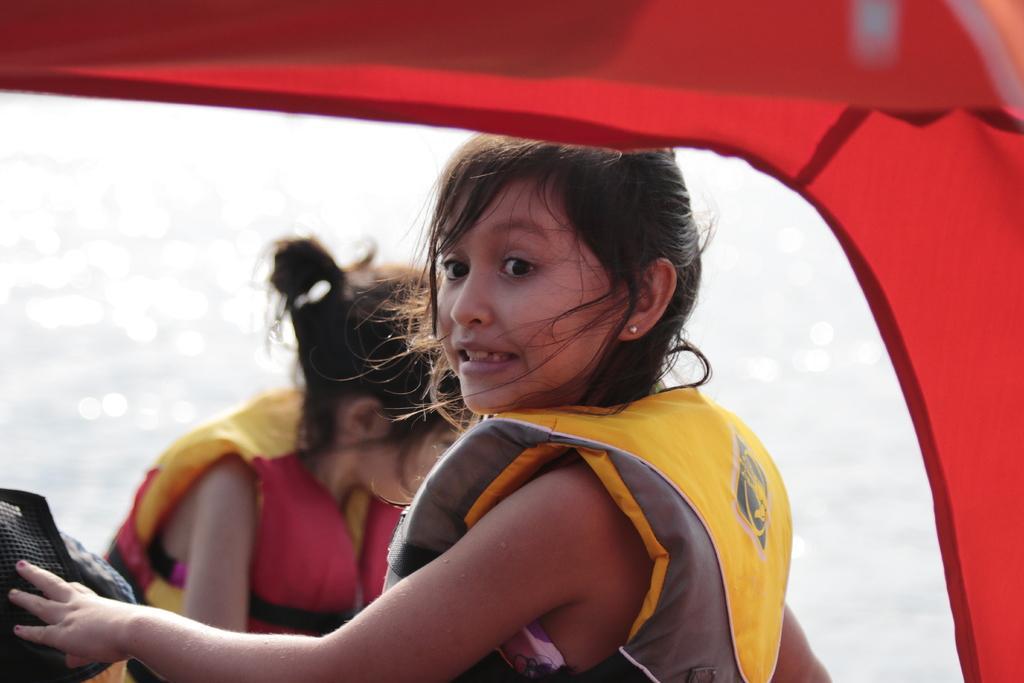Please provide a concise description of this image. In this image we can see a boat, in the boat there are two persons wearing the jackets and also we can see the water. 